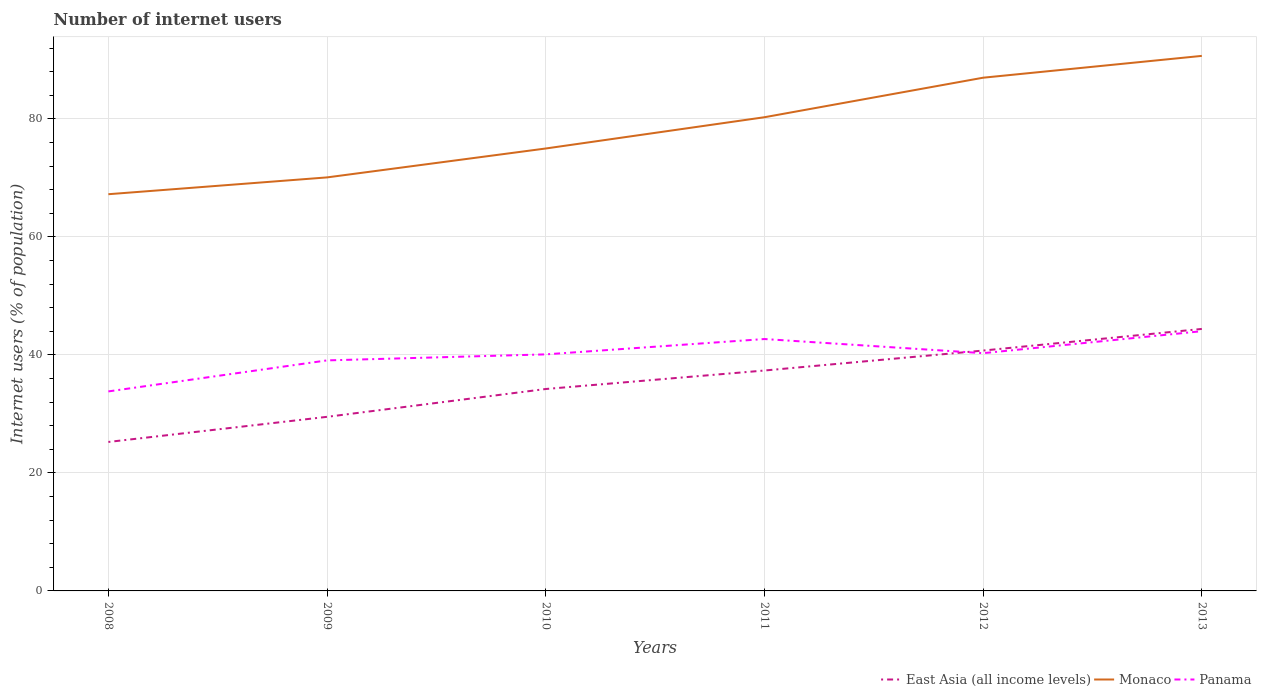Across all years, what is the maximum number of internet users in Panama?
Provide a short and direct response. 33.82. What is the total number of internet users in Monaco in the graph?
Provide a short and direct response. -13.05. What is the difference between the highest and the second highest number of internet users in Monaco?
Your response must be concise. 23.45. Is the number of internet users in Panama strictly greater than the number of internet users in Monaco over the years?
Provide a short and direct response. Yes. How many years are there in the graph?
Make the answer very short. 6. What is the difference between two consecutive major ticks on the Y-axis?
Offer a very short reply. 20. Does the graph contain any zero values?
Ensure brevity in your answer.  No. Does the graph contain grids?
Keep it short and to the point. Yes. Where does the legend appear in the graph?
Your response must be concise. Bottom right. How are the legend labels stacked?
Give a very brief answer. Horizontal. What is the title of the graph?
Provide a succinct answer. Number of internet users. What is the label or title of the X-axis?
Offer a very short reply. Years. What is the label or title of the Y-axis?
Make the answer very short. Internet users (% of population). What is the Internet users (% of population) in East Asia (all income levels) in 2008?
Your answer should be very brief. 25.25. What is the Internet users (% of population) in Monaco in 2008?
Ensure brevity in your answer.  67.25. What is the Internet users (% of population) in Panama in 2008?
Provide a short and direct response. 33.82. What is the Internet users (% of population) of East Asia (all income levels) in 2009?
Offer a terse response. 29.51. What is the Internet users (% of population) of Monaco in 2009?
Make the answer very short. 70.1. What is the Internet users (% of population) of Panama in 2009?
Ensure brevity in your answer.  39.08. What is the Internet users (% of population) in East Asia (all income levels) in 2010?
Make the answer very short. 34.23. What is the Internet users (% of population) in Panama in 2010?
Your response must be concise. 40.1. What is the Internet users (% of population) of East Asia (all income levels) in 2011?
Give a very brief answer. 37.36. What is the Internet users (% of population) of Monaco in 2011?
Ensure brevity in your answer.  80.3. What is the Internet users (% of population) in Panama in 2011?
Provide a short and direct response. 42.7. What is the Internet users (% of population) in East Asia (all income levels) in 2012?
Your answer should be compact. 40.75. What is the Internet users (% of population) of Panama in 2012?
Offer a terse response. 40.3. What is the Internet users (% of population) of East Asia (all income levels) in 2013?
Give a very brief answer. 44.41. What is the Internet users (% of population) in Monaco in 2013?
Your answer should be very brief. 90.7. What is the Internet users (% of population) in Panama in 2013?
Your answer should be very brief. 44.03. Across all years, what is the maximum Internet users (% of population) in East Asia (all income levels)?
Your response must be concise. 44.41. Across all years, what is the maximum Internet users (% of population) in Monaco?
Provide a succinct answer. 90.7. Across all years, what is the maximum Internet users (% of population) of Panama?
Your response must be concise. 44.03. Across all years, what is the minimum Internet users (% of population) in East Asia (all income levels)?
Provide a short and direct response. 25.25. Across all years, what is the minimum Internet users (% of population) of Monaco?
Give a very brief answer. 67.25. Across all years, what is the minimum Internet users (% of population) in Panama?
Give a very brief answer. 33.82. What is the total Internet users (% of population) of East Asia (all income levels) in the graph?
Offer a very short reply. 211.52. What is the total Internet users (% of population) in Monaco in the graph?
Keep it short and to the point. 470.35. What is the total Internet users (% of population) of Panama in the graph?
Your answer should be compact. 240.03. What is the difference between the Internet users (% of population) in East Asia (all income levels) in 2008 and that in 2009?
Your answer should be very brief. -4.26. What is the difference between the Internet users (% of population) in Monaco in 2008 and that in 2009?
Give a very brief answer. -2.85. What is the difference between the Internet users (% of population) in Panama in 2008 and that in 2009?
Ensure brevity in your answer.  -5.26. What is the difference between the Internet users (% of population) in East Asia (all income levels) in 2008 and that in 2010?
Make the answer very short. -8.98. What is the difference between the Internet users (% of population) in Monaco in 2008 and that in 2010?
Keep it short and to the point. -7.75. What is the difference between the Internet users (% of population) of Panama in 2008 and that in 2010?
Offer a terse response. -6.28. What is the difference between the Internet users (% of population) in East Asia (all income levels) in 2008 and that in 2011?
Give a very brief answer. -12.11. What is the difference between the Internet users (% of population) in Monaco in 2008 and that in 2011?
Your response must be concise. -13.05. What is the difference between the Internet users (% of population) in Panama in 2008 and that in 2011?
Your answer should be very brief. -8.88. What is the difference between the Internet users (% of population) in East Asia (all income levels) in 2008 and that in 2012?
Keep it short and to the point. -15.49. What is the difference between the Internet users (% of population) in Monaco in 2008 and that in 2012?
Offer a terse response. -19.75. What is the difference between the Internet users (% of population) in Panama in 2008 and that in 2012?
Give a very brief answer. -6.48. What is the difference between the Internet users (% of population) in East Asia (all income levels) in 2008 and that in 2013?
Make the answer very short. -19.16. What is the difference between the Internet users (% of population) of Monaco in 2008 and that in 2013?
Your answer should be compact. -23.45. What is the difference between the Internet users (% of population) in Panama in 2008 and that in 2013?
Give a very brief answer. -10.21. What is the difference between the Internet users (% of population) in East Asia (all income levels) in 2009 and that in 2010?
Make the answer very short. -4.72. What is the difference between the Internet users (% of population) in Panama in 2009 and that in 2010?
Your answer should be very brief. -1.02. What is the difference between the Internet users (% of population) of East Asia (all income levels) in 2009 and that in 2011?
Ensure brevity in your answer.  -7.85. What is the difference between the Internet users (% of population) of Panama in 2009 and that in 2011?
Your response must be concise. -3.62. What is the difference between the Internet users (% of population) in East Asia (all income levels) in 2009 and that in 2012?
Your answer should be compact. -11.23. What is the difference between the Internet users (% of population) of Monaco in 2009 and that in 2012?
Ensure brevity in your answer.  -16.9. What is the difference between the Internet users (% of population) of Panama in 2009 and that in 2012?
Your response must be concise. -1.22. What is the difference between the Internet users (% of population) in East Asia (all income levels) in 2009 and that in 2013?
Keep it short and to the point. -14.9. What is the difference between the Internet users (% of population) of Monaco in 2009 and that in 2013?
Offer a terse response. -20.6. What is the difference between the Internet users (% of population) in Panama in 2009 and that in 2013?
Provide a short and direct response. -4.95. What is the difference between the Internet users (% of population) in East Asia (all income levels) in 2010 and that in 2011?
Make the answer very short. -3.13. What is the difference between the Internet users (% of population) in East Asia (all income levels) in 2010 and that in 2012?
Offer a very short reply. -6.52. What is the difference between the Internet users (% of population) of Panama in 2010 and that in 2012?
Your answer should be compact. -0.2. What is the difference between the Internet users (% of population) in East Asia (all income levels) in 2010 and that in 2013?
Ensure brevity in your answer.  -10.18. What is the difference between the Internet users (% of population) in Monaco in 2010 and that in 2013?
Your response must be concise. -15.7. What is the difference between the Internet users (% of population) in Panama in 2010 and that in 2013?
Provide a succinct answer. -3.93. What is the difference between the Internet users (% of population) in East Asia (all income levels) in 2011 and that in 2012?
Provide a short and direct response. -3.38. What is the difference between the Internet users (% of population) of Monaco in 2011 and that in 2012?
Give a very brief answer. -6.7. What is the difference between the Internet users (% of population) in Panama in 2011 and that in 2012?
Your answer should be very brief. 2.4. What is the difference between the Internet users (% of population) in East Asia (all income levels) in 2011 and that in 2013?
Make the answer very short. -7.05. What is the difference between the Internet users (% of population) in Monaco in 2011 and that in 2013?
Ensure brevity in your answer.  -10.4. What is the difference between the Internet users (% of population) in Panama in 2011 and that in 2013?
Keep it short and to the point. -1.33. What is the difference between the Internet users (% of population) in East Asia (all income levels) in 2012 and that in 2013?
Provide a succinct answer. -3.67. What is the difference between the Internet users (% of population) in Monaco in 2012 and that in 2013?
Your answer should be very brief. -3.7. What is the difference between the Internet users (% of population) in Panama in 2012 and that in 2013?
Your answer should be compact. -3.73. What is the difference between the Internet users (% of population) in East Asia (all income levels) in 2008 and the Internet users (% of population) in Monaco in 2009?
Provide a short and direct response. -44.85. What is the difference between the Internet users (% of population) in East Asia (all income levels) in 2008 and the Internet users (% of population) in Panama in 2009?
Provide a short and direct response. -13.83. What is the difference between the Internet users (% of population) of Monaco in 2008 and the Internet users (% of population) of Panama in 2009?
Your answer should be very brief. 28.17. What is the difference between the Internet users (% of population) of East Asia (all income levels) in 2008 and the Internet users (% of population) of Monaco in 2010?
Make the answer very short. -49.75. What is the difference between the Internet users (% of population) of East Asia (all income levels) in 2008 and the Internet users (% of population) of Panama in 2010?
Your answer should be very brief. -14.85. What is the difference between the Internet users (% of population) of Monaco in 2008 and the Internet users (% of population) of Panama in 2010?
Offer a very short reply. 27.15. What is the difference between the Internet users (% of population) in East Asia (all income levels) in 2008 and the Internet users (% of population) in Monaco in 2011?
Make the answer very short. -55.05. What is the difference between the Internet users (% of population) of East Asia (all income levels) in 2008 and the Internet users (% of population) of Panama in 2011?
Provide a short and direct response. -17.45. What is the difference between the Internet users (% of population) of Monaco in 2008 and the Internet users (% of population) of Panama in 2011?
Provide a succinct answer. 24.55. What is the difference between the Internet users (% of population) in East Asia (all income levels) in 2008 and the Internet users (% of population) in Monaco in 2012?
Ensure brevity in your answer.  -61.75. What is the difference between the Internet users (% of population) of East Asia (all income levels) in 2008 and the Internet users (% of population) of Panama in 2012?
Your response must be concise. -15.05. What is the difference between the Internet users (% of population) in Monaco in 2008 and the Internet users (% of population) in Panama in 2012?
Keep it short and to the point. 26.95. What is the difference between the Internet users (% of population) in East Asia (all income levels) in 2008 and the Internet users (% of population) in Monaco in 2013?
Make the answer very short. -65.45. What is the difference between the Internet users (% of population) of East Asia (all income levels) in 2008 and the Internet users (% of population) of Panama in 2013?
Your response must be concise. -18.78. What is the difference between the Internet users (% of population) of Monaco in 2008 and the Internet users (% of population) of Panama in 2013?
Keep it short and to the point. 23.22. What is the difference between the Internet users (% of population) of East Asia (all income levels) in 2009 and the Internet users (% of population) of Monaco in 2010?
Give a very brief answer. -45.49. What is the difference between the Internet users (% of population) in East Asia (all income levels) in 2009 and the Internet users (% of population) in Panama in 2010?
Make the answer very short. -10.59. What is the difference between the Internet users (% of population) in Monaco in 2009 and the Internet users (% of population) in Panama in 2010?
Your answer should be compact. 30. What is the difference between the Internet users (% of population) of East Asia (all income levels) in 2009 and the Internet users (% of population) of Monaco in 2011?
Your response must be concise. -50.79. What is the difference between the Internet users (% of population) in East Asia (all income levels) in 2009 and the Internet users (% of population) in Panama in 2011?
Provide a succinct answer. -13.19. What is the difference between the Internet users (% of population) of Monaco in 2009 and the Internet users (% of population) of Panama in 2011?
Give a very brief answer. 27.4. What is the difference between the Internet users (% of population) in East Asia (all income levels) in 2009 and the Internet users (% of population) in Monaco in 2012?
Provide a short and direct response. -57.49. What is the difference between the Internet users (% of population) in East Asia (all income levels) in 2009 and the Internet users (% of population) in Panama in 2012?
Ensure brevity in your answer.  -10.79. What is the difference between the Internet users (% of population) in Monaco in 2009 and the Internet users (% of population) in Panama in 2012?
Make the answer very short. 29.8. What is the difference between the Internet users (% of population) in East Asia (all income levels) in 2009 and the Internet users (% of population) in Monaco in 2013?
Provide a short and direct response. -61.19. What is the difference between the Internet users (% of population) of East Asia (all income levels) in 2009 and the Internet users (% of population) of Panama in 2013?
Offer a terse response. -14.52. What is the difference between the Internet users (% of population) of Monaco in 2009 and the Internet users (% of population) of Panama in 2013?
Keep it short and to the point. 26.07. What is the difference between the Internet users (% of population) in East Asia (all income levels) in 2010 and the Internet users (% of population) in Monaco in 2011?
Offer a terse response. -46.07. What is the difference between the Internet users (% of population) in East Asia (all income levels) in 2010 and the Internet users (% of population) in Panama in 2011?
Offer a very short reply. -8.47. What is the difference between the Internet users (% of population) in Monaco in 2010 and the Internet users (% of population) in Panama in 2011?
Keep it short and to the point. 32.3. What is the difference between the Internet users (% of population) of East Asia (all income levels) in 2010 and the Internet users (% of population) of Monaco in 2012?
Your answer should be compact. -52.77. What is the difference between the Internet users (% of population) in East Asia (all income levels) in 2010 and the Internet users (% of population) in Panama in 2012?
Your response must be concise. -6.07. What is the difference between the Internet users (% of population) in Monaco in 2010 and the Internet users (% of population) in Panama in 2012?
Ensure brevity in your answer.  34.7. What is the difference between the Internet users (% of population) in East Asia (all income levels) in 2010 and the Internet users (% of population) in Monaco in 2013?
Keep it short and to the point. -56.47. What is the difference between the Internet users (% of population) of East Asia (all income levels) in 2010 and the Internet users (% of population) of Panama in 2013?
Ensure brevity in your answer.  -9.8. What is the difference between the Internet users (% of population) of Monaco in 2010 and the Internet users (% of population) of Panama in 2013?
Make the answer very short. 30.97. What is the difference between the Internet users (% of population) in East Asia (all income levels) in 2011 and the Internet users (% of population) in Monaco in 2012?
Offer a very short reply. -49.64. What is the difference between the Internet users (% of population) in East Asia (all income levels) in 2011 and the Internet users (% of population) in Panama in 2012?
Make the answer very short. -2.94. What is the difference between the Internet users (% of population) of Monaco in 2011 and the Internet users (% of population) of Panama in 2012?
Make the answer very short. 40. What is the difference between the Internet users (% of population) of East Asia (all income levels) in 2011 and the Internet users (% of population) of Monaco in 2013?
Your answer should be very brief. -53.34. What is the difference between the Internet users (% of population) in East Asia (all income levels) in 2011 and the Internet users (% of population) in Panama in 2013?
Provide a succinct answer. -6.67. What is the difference between the Internet users (% of population) of Monaco in 2011 and the Internet users (% of population) of Panama in 2013?
Ensure brevity in your answer.  36.27. What is the difference between the Internet users (% of population) in East Asia (all income levels) in 2012 and the Internet users (% of population) in Monaco in 2013?
Your answer should be compact. -49.95. What is the difference between the Internet users (% of population) in East Asia (all income levels) in 2012 and the Internet users (% of population) in Panama in 2013?
Provide a succinct answer. -3.28. What is the difference between the Internet users (% of population) of Monaco in 2012 and the Internet users (% of population) of Panama in 2013?
Your response must be concise. 42.97. What is the average Internet users (% of population) of East Asia (all income levels) per year?
Offer a terse response. 35.25. What is the average Internet users (% of population) in Monaco per year?
Your answer should be compact. 78.39. What is the average Internet users (% of population) of Panama per year?
Provide a short and direct response. 40.01. In the year 2008, what is the difference between the Internet users (% of population) of East Asia (all income levels) and Internet users (% of population) of Monaco?
Make the answer very short. -42. In the year 2008, what is the difference between the Internet users (% of population) of East Asia (all income levels) and Internet users (% of population) of Panama?
Keep it short and to the point. -8.57. In the year 2008, what is the difference between the Internet users (% of population) in Monaco and Internet users (% of population) in Panama?
Your answer should be very brief. 33.43. In the year 2009, what is the difference between the Internet users (% of population) of East Asia (all income levels) and Internet users (% of population) of Monaco?
Ensure brevity in your answer.  -40.59. In the year 2009, what is the difference between the Internet users (% of population) in East Asia (all income levels) and Internet users (% of population) in Panama?
Keep it short and to the point. -9.57. In the year 2009, what is the difference between the Internet users (% of population) in Monaco and Internet users (% of population) in Panama?
Give a very brief answer. 31.02. In the year 2010, what is the difference between the Internet users (% of population) of East Asia (all income levels) and Internet users (% of population) of Monaco?
Your response must be concise. -40.77. In the year 2010, what is the difference between the Internet users (% of population) in East Asia (all income levels) and Internet users (% of population) in Panama?
Offer a terse response. -5.87. In the year 2010, what is the difference between the Internet users (% of population) in Monaco and Internet users (% of population) in Panama?
Provide a short and direct response. 34.9. In the year 2011, what is the difference between the Internet users (% of population) in East Asia (all income levels) and Internet users (% of population) in Monaco?
Your response must be concise. -42.94. In the year 2011, what is the difference between the Internet users (% of population) in East Asia (all income levels) and Internet users (% of population) in Panama?
Keep it short and to the point. -5.34. In the year 2011, what is the difference between the Internet users (% of population) of Monaco and Internet users (% of population) of Panama?
Provide a succinct answer. 37.6. In the year 2012, what is the difference between the Internet users (% of population) of East Asia (all income levels) and Internet users (% of population) of Monaco?
Offer a very short reply. -46.25. In the year 2012, what is the difference between the Internet users (% of population) in East Asia (all income levels) and Internet users (% of population) in Panama?
Offer a very short reply. 0.44. In the year 2012, what is the difference between the Internet users (% of population) in Monaco and Internet users (% of population) in Panama?
Provide a succinct answer. 46.7. In the year 2013, what is the difference between the Internet users (% of population) of East Asia (all income levels) and Internet users (% of population) of Monaco?
Your answer should be very brief. -46.29. In the year 2013, what is the difference between the Internet users (% of population) of East Asia (all income levels) and Internet users (% of population) of Panama?
Your answer should be compact. 0.38. In the year 2013, what is the difference between the Internet users (% of population) in Monaco and Internet users (% of population) in Panama?
Make the answer very short. 46.67. What is the ratio of the Internet users (% of population) in East Asia (all income levels) in 2008 to that in 2009?
Provide a short and direct response. 0.86. What is the ratio of the Internet users (% of population) of Monaco in 2008 to that in 2009?
Provide a short and direct response. 0.96. What is the ratio of the Internet users (% of population) of Panama in 2008 to that in 2009?
Your answer should be compact. 0.87. What is the ratio of the Internet users (% of population) of East Asia (all income levels) in 2008 to that in 2010?
Offer a terse response. 0.74. What is the ratio of the Internet users (% of population) in Monaco in 2008 to that in 2010?
Offer a very short reply. 0.9. What is the ratio of the Internet users (% of population) of Panama in 2008 to that in 2010?
Your response must be concise. 0.84. What is the ratio of the Internet users (% of population) in East Asia (all income levels) in 2008 to that in 2011?
Provide a short and direct response. 0.68. What is the ratio of the Internet users (% of population) in Monaco in 2008 to that in 2011?
Offer a terse response. 0.84. What is the ratio of the Internet users (% of population) in Panama in 2008 to that in 2011?
Ensure brevity in your answer.  0.79. What is the ratio of the Internet users (% of population) of East Asia (all income levels) in 2008 to that in 2012?
Your response must be concise. 0.62. What is the ratio of the Internet users (% of population) in Monaco in 2008 to that in 2012?
Keep it short and to the point. 0.77. What is the ratio of the Internet users (% of population) in Panama in 2008 to that in 2012?
Offer a terse response. 0.84. What is the ratio of the Internet users (% of population) in East Asia (all income levels) in 2008 to that in 2013?
Provide a succinct answer. 0.57. What is the ratio of the Internet users (% of population) in Monaco in 2008 to that in 2013?
Your response must be concise. 0.74. What is the ratio of the Internet users (% of population) in Panama in 2008 to that in 2013?
Your answer should be compact. 0.77. What is the ratio of the Internet users (% of population) of East Asia (all income levels) in 2009 to that in 2010?
Your response must be concise. 0.86. What is the ratio of the Internet users (% of population) in Monaco in 2009 to that in 2010?
Offer a terse response. 0.93. What is the ratio of the Internet users (% of population) of Panama in 2009 to that in 2010?
Your response must be concise. 0.97. What is the ratio of the Internet users (% of population) in East Asia (all income levels) in 2009 to that in 2011?
Make the answer very short. 0.79. What is the ratio of the Internet users (% of population) of Monaco in 2009 to that in 2011?
Offer a very short reply. 0.87. What is the ratio of the Internet users (% of population) of Panama in 2009 to that in 2011?
Give a very brief answer. 0.92. What is the ratio of the Internet users (% of population) of East Asia (all income levels) in 2009 to that in 2012?
Give a very brief answer. 0.72. What is the ratio of the Internet users (% of population) of Monaco in 2009 to that in 2012?
Provide a short and direct response. 0.81. What is the ratio of the Internet users (% of population) of Panama in 2009 to that in 2012?
Keep it short and to the point. 0.97. What is the ratio of the Internet users (% of population) of East Asia (all income levels) in 2009 to that in 2013?
Offer a very short reply. 0.66. What is the ratio of the Internet users (% of population) in Monaco in 2009 to that in 2013?
Offer a very short reply. 0.77. What is the ratio of the Internet users (% of population) of Panama in 2009 to that in 2013?
Ensure brevity in your answer.  0.89. What is the ratio of the Internet users (% of population) of East Asia (all income levels) in 2010 to that in 2011?
Your answer should be compact. 0.92. What is the ratio of the Internet users (% of population) in Monaco in 2010 to that in 2011?
Offer a very short reply. 0.93. What is the ratio of the Internet users (% of population) of Panama in 2010 to that in 2011?
Provide a short and direct response. 0.94. What is the ratio of the Internet users (% of population) of East Asia (all income levels) in 2010 to that in 2012?
Ensure brevity in your answer.  0.84. What is the ratio of the Internet users (% of population) in Monaco in 2010 to that in 2012?
Your response must be concise. 0.86. What is the ratio of the Internet users (% of population) in Panama in 2010 to that in 2012?
Your response must be concise. 0.99. What is the ratio of the Internet users (% of population) of East Asia (all income levels) in 2010 to that in 2013?
Make the answer very short. 0.77. What is the ratio of the Internet users (% of population) of Monaco in 2010 to that in 2013?
Your answer should be compact. 0.83. What is the ratio of the Internet users (% of population) in Panama in 2010 to that in 2013?
Your answer should be compact. 0.91. What is the ratio of the Internet users (% of population) in East Asia (all income levels) in 2011 to that in 2012?
Keep it short and to the point. 0.92. What is the ratio of the Internet users (% of population) of Monaco in 2011 to that in 2012?
Your response must be concise. 0.92. What is the ratio of the Internet users (% of population) in Panama in 2011 to that in 2012?
Give a very brief answer. 1.06. What is the ratio of the Internet users (% of population) of East Asia (all income levels) in 2011 to that in 2013?
Provide a short and direct response. 0.84. What is the ratio of the Internet users (% of population) in Monaco in 2011 to that in 2013?
Your answer should be very brief. 0.89. What is the ratio of the Internet users (% of population) in Panama in 2011 to that in 2013?
Provide a short and direct response. 0.97. What is the ratio of the Internet users (% of population) in East Asia (all income levels) in 2012 to that in 2013?
Ensure brevity in your answer.  0.92. What is the ratio of the Internet users (% of population) of Monaco in 2012 to that in 2013?
Provide a short and direct response. 0.96. What is the ratio of the Internet users (% of population) in Panama in 2012 to that in 2013?
Ensure brevity in your answer.  0.92. What is the difference between the highest and the second highest Internet users (% of population) of East Asia (all income levels)?
Keep it short and to the point. 3.67. What is the difference between the highest and the second highest Internet users (% of population) of Monaco?
Provide a short and direct response. 3.7. What is the difference between the highest and the second highest Internet users (% of population) in Panama?
Provide a short and direct response. 1.33. What is the difference between the highest and the lowest Internet users (% of population) in East Asia (all income levels)?
Offer a terse response. 19.16. What is the difference between the highest and the lowest Internet users (% of population) in Monaco?
Keep it short and to the point. 23.45. What is the difference between the highest and the lowest Internet users (% of population) of Panama?
Your response must be concise. 10.21. 